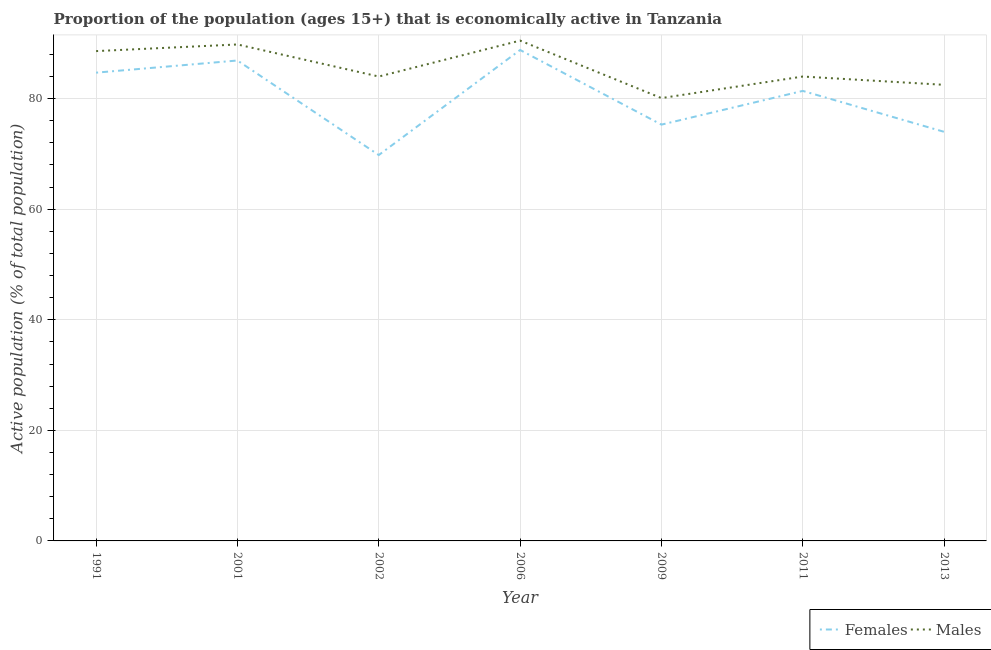Does the line corresponding to percentage of economically active female population intersect with the line corresponding to percentage of economically active male population?
Give a very brief answer. No. What is the percentage of economically active female population in 2013?
Offer a very short reply. 74. Across all years, what is the maximum percentage of economically active male population?
Provide a short and direct response. 90.5. Across all years, what is the minimum percentage of economically active female population?
Provide a succinct answer. 69.8. In which year was the percentage of economically active female population maximum?
Offer a very short reply. 2006. In which year was the percentage of economically active female population minimum?
Give a very brief answer. 2002. What is the total percentage of economically active female population in the graph?
Your response must be concise. 560.9. What is the difference between the percentage of economically active male population in 2001 and that in 2006?
Offer a terse response. -0.7. What is the difference between the percentage of economically active male population in 2009 and the percentage of economically active female population in 2006?
Make the answer very short. -8.7. What is the average percentage of economically active male population per year?
Keep it short and to the point. 85.64. In the year 1991, what is the difference between the percentage of economically active male population and percentage of economically active female population?
Your answer should be very brief. 3.9. In how many years, is the percentage of economically active male population greater than 52 %?
Your response must be concise. 7. What is the ratio of the percentage of economically active male population in 2001 to that in 2013?
Your answer should be very brief. 1.09. Is the difference between the percentage of economically active female population in 1991 and 2013 greater than the difference between the percentage of economically active male population in 1991 and 2013?
Provide a short and direct response. Yes. What is the difference between the highest and the second highest percentage of economically active male population?
Your answer should be very brief. 0.7. In how many years, is the percentage of economically active male population greater than the average percentage of economically active male population taken over all years?
Your answer should be compact. 3. Does the percentage of economically active female population monotonically increase over the years?
Ensure brevity in your answer.  No. Is the percentage of economically active female population strictly greater than the percentage of economically active male population over the years?
Provide a succinct answer. No. Is the percentage of economically active male population strictly less than the percentage of economically active female population over the years?
Offer a terse response. No. How many lines are there?
Your response must be concise. 2. Does the graph contain any zero values?
Your response must be concise. No. Does the graph contain grids?
Offer a terse response. Yes. Where does the legend appear in the graph?
Your answer should be very brief. Bottom right. How many legend labels are there?
Offer a terse response. 2. How are the legend labels stacked?
Provide a succinct answer. Horizontal. What is the title of the graph?
Give a very brief answer. Proportion of the population (ages 15+) that is economically active in Tanzania. Does "Nitrous oxide emissions" appear as one of the legend labels in the graph?
Keep it short and to the point. No. What is the label or title of the X-axis?
Provide a succinct answer. Year. What is the label or title of the Y-axis?
Your response must be concise. Active population (% of total population). What is the Active population (% of total population) in Females in 1991?
Provide a short and direct response. 84.7. What is the Active population (% of total population) of Males in 1991?
Keep it short and to the point. 88.6. What is the Active population (% of total population) in Females in 2001?
Provide a succinct answer. 86.9. What is the Active population (% of total population) in Males in 2001?
Keep it short and to the point. 89.8. What is the Active population (% of total population) of Females in 2002?
Your answer should be very brief. 69.8. What is the Active population (% of total population) in Females in 2006?
Offer a terse response. 88.8. What is the Active population (% of total population) of Males in 2006?
Offer a terse response. 90.5. What is the Active population (% of total population) in Females in 2009?
Ensure brevity in your answer.  75.3. What is the Active population (% of total population) in Males in 2009?
Provide a succinct answer. 80.1. What is the Active population (% of total population) of Females in 2011?
Your answer should be compact. 81.4. What is the Active population (% of total population) in Males in 2013?
Give a very brief answer. 82.5. Across all years, what is the maximum Active population (% of total population) of Females?
Make the answer very short. 88.8. Across all years, what is the maximum Active population (% of total population) in Males?
Make the answer very short. 90.5. Across all years, what is the minimum Active population (% of total population) of Females?
Offer a very short reply. 69.8. Across all years, what is the minimum Active population (% of total population) in Males?
Offer a very short reply. 80.1. What is the total Active population (% of total population) of Females in the graph?
Offer a very short reply. 560.9. What is the total Active population (% of total population) in Males in the graph?
Provide a short and direct response. 599.5. What is the difference between the Active population (% of total population) in Males in 1991 and that in 2001?
Keep it short and to the point. -1.2. What is the difference between the Active population (% of total population) in Females in 1991 and that in 2002?
Ensure brevity in your answer.  14.9. What is the difference between the Active population (% of total population) in Males in 1991 and that in 2002?
Your response must be concise. 4.6. What is the difference between the Active population (% of total population) in Females in 1991 and that in 2006?
Offer a terse response. -4.1. What is the difference between the Active population (% of total population) in Females in 1991 and that in 2013?
Your response must be concise. 10.7. What is the difference between the Active population (% of total population) of Males in 2001 and that in 2002?
Offer a very short reply. 5.8. What is the difference between the Active population (% of total population) of Males in 2001 and that in 2006?
Your response must be concise. -0.7. What is the difference between the Active population (% of total population) in Males in 2001 and that in 2009?
Provide a short and direct response. 9.7. What is the difference between the Active population (% of total population) of Females in 2001 and that in 2011?
Ensure brevity in your answer.  5.5. What is the difference between the Active population (% of total population) in Males in 2001 and that in 2011?
Make the answer very short. 5.8. What is the difference between the Active population (% of total population) in Females in 2001 and that in 2013?
Your answer should be compact. 12.9. What is the difference between the Active population (% of total population) in Females in 2002 and that in 2011?
Offer a very short reply. -11.6. What is the difference between the Active population (% of total population) in Males in 2002 and that in 2011?
Ensure brevity in your answer.  0. What is the difference between the Active population (% of total population) of Males in 2002 and that in 2013?
Offer a terse response. 1.5. What is the difference between the Active population (% of total population) in Females in 2006 and that in 2009?
Offer a terse response. 13.5. What is the difference between the Active population (% of total population) of Females in 2009 and that in 2011?
Your answer should be compact. -6.1. What is the difference between the Active population (% of total population) in Females in 1991 and the Active population (% of total population) in Males in 2002?
Your answer should be compact. 0.7. What is the difference between the Active population (% of total population) in Females in 1991 and the Active population (% of total population) in Males in 2011?
Give a very brief answer. 0.7. What is the difference between the Active population (% of total population) of Females in 2001 and the Active population (% of total population) of Males in 2006?
Keep it short and to the point. -3.6. What is the difference between the Active population (% of total population) of Females in 2001 and the Active population (% of total population) of Males in 2011?
Provide a short and direct response. 2.9. What is the difference between the Active population (% of total population) in Females in 2001 and the Active population (% of total population) in Males in 2013?
Keep it short and to the point. 4.4. What is the difference between the Active population (% of total population) of Females in 2002 and the Active population (% of total population) of Males in 2006?
Offer a terse response. -20.7. What is the difference between the Active population (% of total population) in Females in 2002 and the Active population (% of total population) in Males in 2009?
Keep it short and to the point. -10.3. What is the difference between the Active population (% of total population) in Females in 2006 and the Active population (% of total population) in Males in 2009?
Keep it short and to the point. 8.7. What is the difference between the Active population (% of total population) of Females in 2006 and the Active population (% of total population) of Males in 2013?
Provide a short and direct response. 6.3. What is the difference between the Active population (% of total population) of Females in 2011 and the Active population (% of total population) of Males in 2013?
Offer a terse response. -1.1. What is the average Active population (% of total population) in Females per year?
Your response must be concise. 80.13. What is the average Active population (% of total population) in Males per year?
Provide a short and direct response. 85.64. In the year 2002, what is the difference between the Active population (% of total population) in Females and Active population (% of total population) in Males?
Provide a succinct answer. -14.2. In the year 2006, what is the difference between the Active population (% of total population) of Females and Active population (% of total population) of Males?
Ensure brevity in your answer.  -1.7. What is the ratio of the Active population (% of total population) in Females in 1991 to that in 2001?
Offer a very short reply. 0.97. What is the ratio of the Active population (% of total population) in Males in 1991 to that in 2001?
Keep it short and to the point. 0.99. What is the ratio of the Active population (% of total population) of Females in 1991 to that in 2002?
Provide a succinct answer. 1.21. What is the ratio of the Active population (% of total population) in Males in 1991 to that in 2002?
Offer a very short reply. 1.05. What is the ratio of the Active population (% of total population) in Females in 1991 to that in 2006?
Offer a terse response. 0.95. What is the ratio of the Active population (% of total population) of Males in 1991 to that in 2006?
Offer a very short reply. 0.98. What is the ratio of the Active population (% of total population) in Females in 1991 to that in 2009?
Offer a very short reply. 1.12. What is the ratio of the Active population (% of total population) of Males in 1991 to that in 2009?
Offer a terse response. 1.11. What is the ratio of the Active population (% of total population) of Females in 1991 to that in 2011?
Give a very brief answer. 1.04. What is the ratio of the Active population (% of total population) in Males in 1991 to that in 2011?
Give a very brief answer. 1.05. What is the ratio of the Active population (% of total population) of Females in 1991 to that in 2013?
Offer a very short reply. 1.14. What is the ratio of the Active population (% of total population) in Males in 1991 to that in 2013?
Make the answer very short. 1.07. What is the ratio of the Active population (% of total population) in Females in 2001 to that in 2002?
Provide a short and direct response. 1.25. What is the ratio of the Active population (% of total population) in Males in 2001 to that in 2002?
Ensure brevity in your answer.  1.07. What is the ratio of the Active population (% of total population) of Females in 2001 to that in 2006?
Offer a terse response. 0.98. What is the ratio of the Active population (% of total population) in Males in 2001 to that in 2006?
Ensure brevity in your answer.  0.99. What is the ratio of the Active population (% of total population) of Females in 2001 to that in 2009?
Make the answer very short. 1.15. What is the ratio of the Active population (% of total population) in Males in 2001 to that in 2009?
Keep it short and to the point. 1.12. What is the ratio of the Active population (% of total population) of Females in 2001 to that in 2011?
Your response must be concise. 1.07. What is the ratio of the Active population (% of total population) of Males in 2001 to that in 2011?
Provide a succinct answer. 1.07. What is the ratio of the Active population (% of total population) of Females in 2001 to that in 2013?
Provide a succinct answer. 1.17. What is the ratio of the Active population (% of total population) of Males in 2001 to that in 2013?
Your answer should be compact. 1.09. What is the ratio of the Active population (% of total population) in Females in 2002 to that in 2006?
Your answer should be compact. 0.79. What is the ratio of the Active population (% of total population) of Males in 2002 to that in 2006?
Your answer should be compact. 0.93. What is the ratio of the Active population (% of total population) of Females in 2002 to that in 2009?
Give a very brief answer. 0.93. What is the ratio of the Active population (% of total population) of Males in 2002 to that in 2009?
Provide a succinct answer. 1.05. What is the ratio of the Active population (% of total population) in Females in 2002 to that in 2011?
Keep it short and to the point. 0.86. What is the ratio of the Active population (% of total population) of Males in 2002 to that in 2011?
Your answer should be compact. 1. What is the ratio of the Active population (% of total population) of Females in 2002 to that in 2013?
Give a very brief answer. 0.94. What is the ratio of the Active population (% of total population) in Males in 2002 to that in 2013?
Offer a very short reply. 1.02. What is the ratio of the Active population (% of total population) of Females in 2006 to that in 2009?
Make the answer very short. 1.18. What is the ratio of the Active population (% of total population) in Males in 2006 to that in 2009?
Offer a terse response. 1.13. What is the ratio of the Active population (% of total population) in Males in 2006 to that in 2011?
Offer a very short reply. 1.08. What is the ratio of the Active population (% of total population) in Males in 2006 to that in 2013?
Offer a terse response. 1.1. What is the ratio of the Active population (% of total population) in Females in 2009 to that in 2011?
Keep it short and to the point. 0.93. What is the ratio of the Active population (% of total population) of Males in 2009 to that in 2011?
Keep it short and to the point. 0.95. What is the ratio of the Active population (% of total population) of Females in 2009 to that in 2013?
Give a very brief answer. 1.02. What is the ratio of the Active population (% of total population) in Males in 2009 to that in 2013?
Provide a short and direct response. 0.97. What is the ratio of the Active population (% of total population) in Females in 2011 to that in 2013?
Your response must be concise. 1.1. What is the ratio of the Active population (% of total population) in Males in 2011 to that in 2013?
Provide a succinct answer. 1.02. What is the difference between the highest and the second highest Active population (% of total population) in Females?
Keep it short and to the point. 1.9. What is the difference between the highest and the lowest Active population (% of total population) of Females?
Your answer should be very brief. 19. 